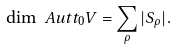Convert formula to latex. <formula><loc_0><loc_0><loc_500><loc_500>\dim \ A u t t _ { 0 } V = \sum _ { \rho } | S _ { \rho } | .</formula> 